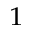Convert formula to latex. <formula><loc_0><loc_0><loc_500><loc_500>^ { 1 }</formula> 